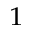Convert formula to latex. <formula><loc_0><loc_0><loc_500><loc_500>^ { 1 }</formula> 